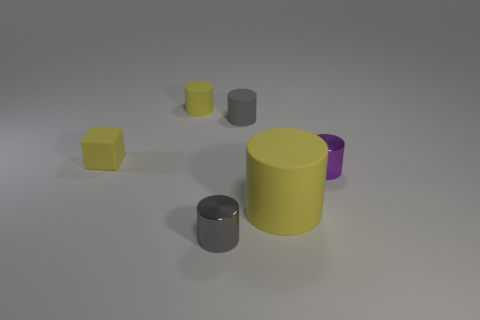Are there an equal number of large yellow cylinders that are behind the purple cylinder and large cylinders that are in front of the block?
Offer a terse response. No. There is a purple metallic cylinder; are there any yellow blocks behind it?
Give a very brief answer. Yes. The shiny cylinder that is on the left side of the purple shiny thing is what color?
Ensure brevity in your answer.  Gray. There is a tiny cylinder behind the gray matte object that is behind the tiny purple object; what is it made of?
Offer a very short reply. Rubber. Is the number of yellow matte cubes that are on the right side of the big yellow cylinder less than the number of tiny gray objects left of the gray metallic thing?
Your response must be concise. No. How many purple things are big matte balls or tiny metal cylinders?
Your answer should be compact. 1. Is the number of gray matte cylinders in front of the gray metallic cylinder the same as the number of blue rubber cubes?
Your answer should be very brief. Yes. How many objects are either large green shiny cylinders or things behind the purple metallic cylinder?
Your answer should be very brief. 3. Is the color of the small rubber block the same as the big thing?
Keep it short and to the point. Yes. Are there any cylinders made of the same material as the large yellow object?
Provide a short and direct response. Yes. 